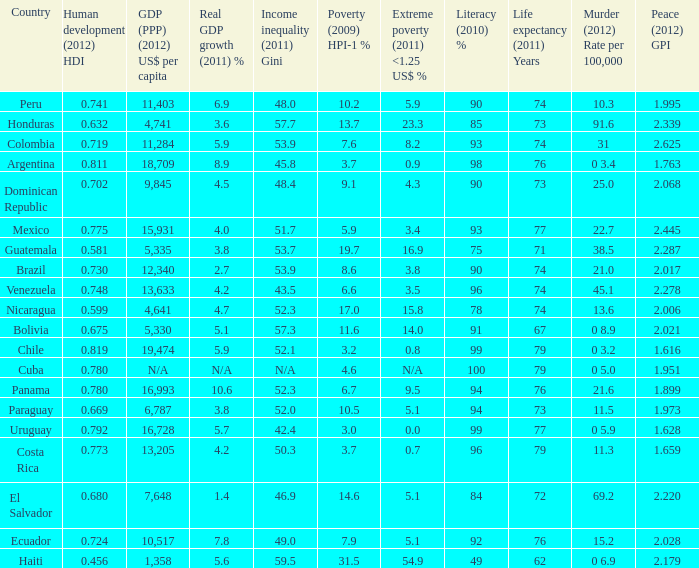What is the total poverty (2009) HPI-1 % when the extreme poverty (2011) <1.25 US$ % of 16.9, and the human development (2012) HDI is less than 0.581? None. 